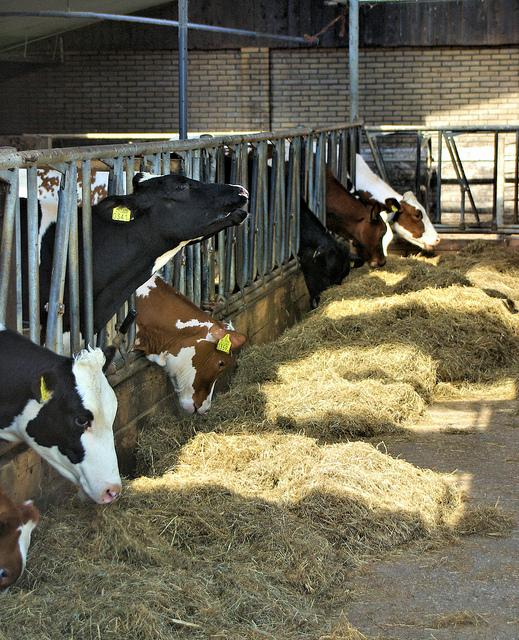Which way is the black cow with yellow tag facing? right 